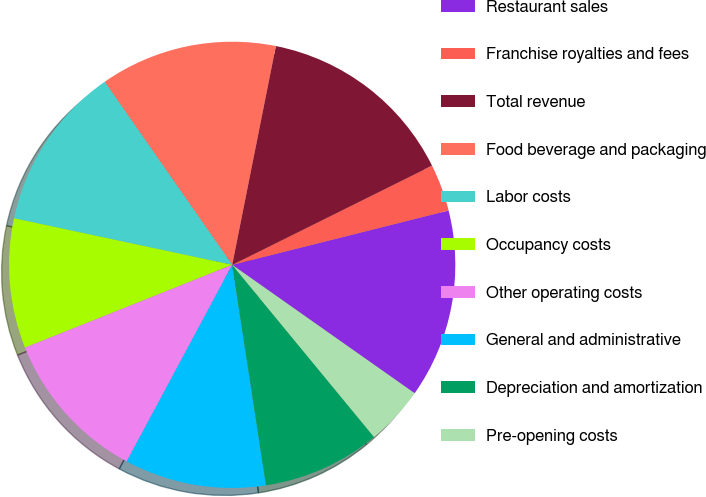Convert chart. <chart><loc_0><loc_0><loc_500><loc_500><pie_chart><fcel>Restaurant sales<fcel>Franchise royalties and fees<fcel>Total revenue<fcel>Food beverage and packaging<fcel>Labor costs<fcel>Occupancy costs<fcel>Other operating costs<fcel>General and administrative<fcel>Depreciation and amortization<fcel>Pre-opening costs<nl><fcel>13.68%<fcel>3.42%<fcel>14.53%<fcel>12.82%<fcel>11.97%<fcel>9.4%<fcel>11.11%<fcel>10.26%<fcel>8.55%<fcel>4.27%<nl></chart> 